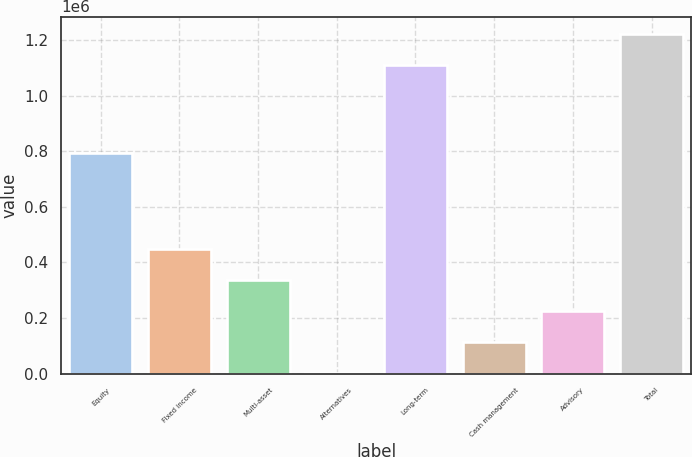Convert chart. <chart><loc_0><loc_0><loc_500><loc_500><bar_chart><fcel>Equity<fcel>Fixed income<fcel>Multi-asset<fcel>Alternatives<fcel>Long-term<fcel>Cash management<fcel>Advisory<fcel>Total<nl><fcel>792099<fcel>447465<fcel>335834<fcel>941<fcel>1.11181e+06<fcel>112572<fcel>224203<fcel>1.22344e+06<nl></chart> 